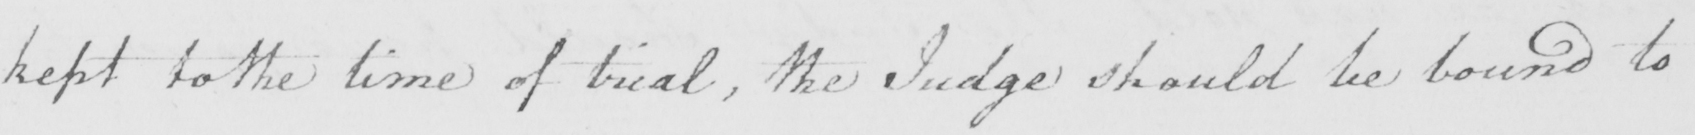What is written in this line of handwriting? kept to the time of trial , the Judge should be bound to 